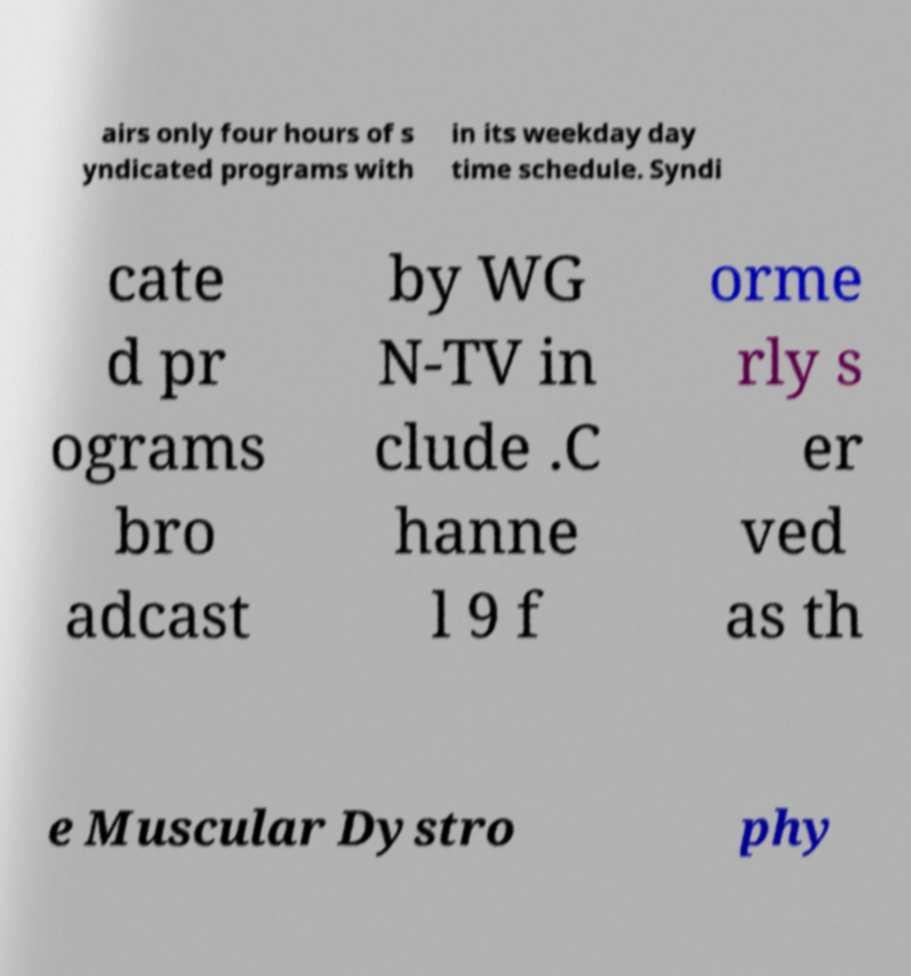Please read and relay the text visible in this image. What does it say? airs only four hours of s yndicated programs with in its weekday day time schedule. Syndi cate d pr ograms bro adcast by WG N-TV in clude .C hanne l 9 f orme rly s er ved as th e Muscular Dystro phy 